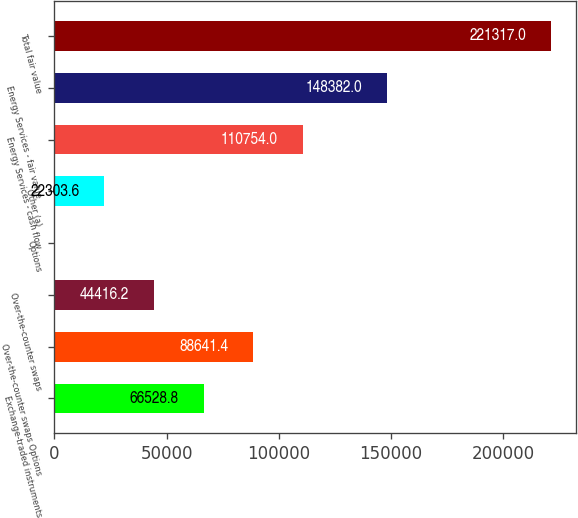Convert chart. <chart><loc_0><loc_0><loc_500><loc_500><bar_chart><fcel>Exchange-traded instruments<fcel>Over-the-counter swaps Options<fcel>Over-the-counter swaps<fcel>Options<fcel>Other (a)<fcel>Energy Services - cash flow<fcel>Energy Services - fair value<fcel>Total fair value<nl><fcel>66528.8<fcel>88641.4<fcel>44416.2<fcel>191<fcel>22303.6<fcel>110754<fcel>148382<fcel>221317<nl></chart> 